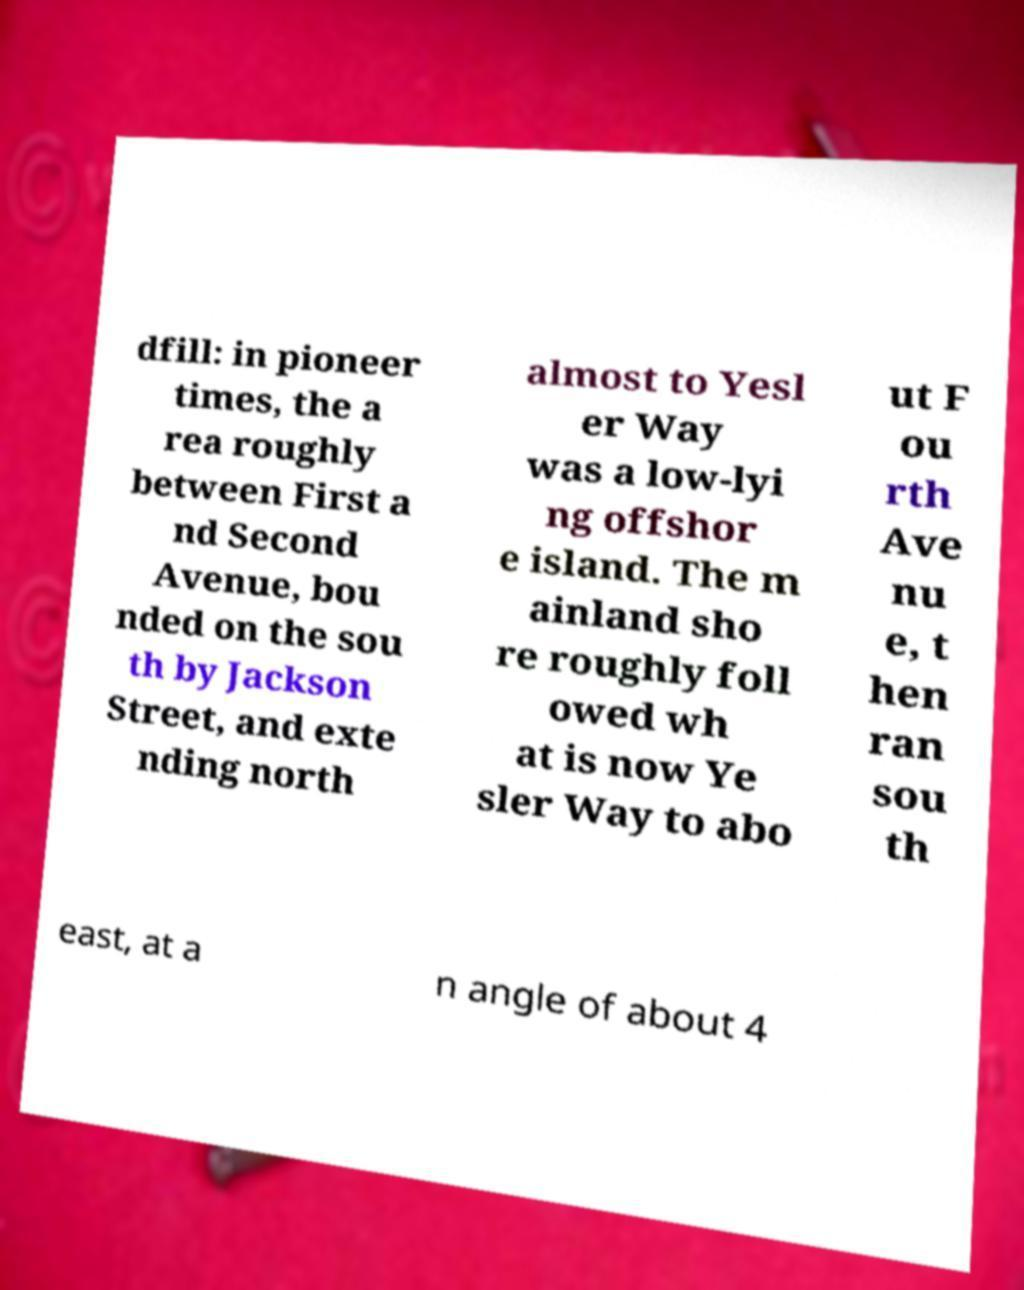Please identify and transcribe the text found in this image. dfill: in pioneer times, the a rea roughly between First a nd Second Avenue, bou nded on the sou th by Jackson Street, and exte nding north almost to Yesl er Way was a low-lyi ng offshor e island. The m ainland sho re roughly foll owed wh at is now Ye sler Way to abo ut F ou rth Ave nu e, t hen ran sou th east, at a n angle of about 4 